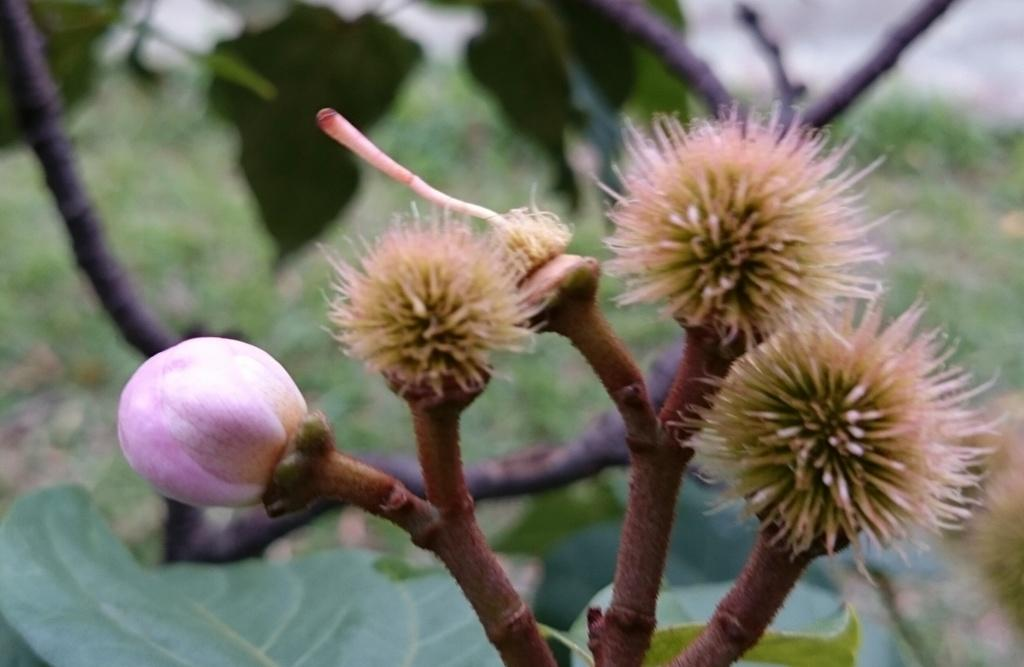What type of vegetation can be seen in the image? There are flowers and plants in the image. Can you describe the leaves visible behind the plants? Yes, there are leaves visible behind the plants in the image. How many apples are hanging from the flowers in the image? There are no apples present in the image; it features flowers and plants. What type of pen can be seen writing on the leaves in the image? There is no pen or writing present on the leaves in the image. 